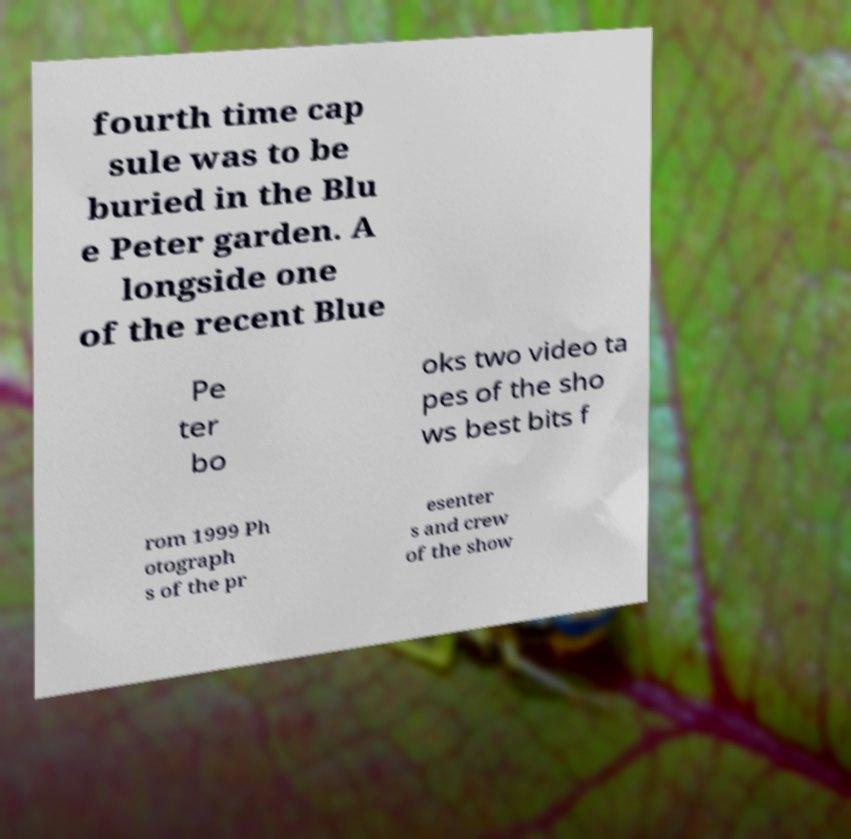Please identify and transcribe the text found in this image. fourth time cap sule was to be buried in the Blu e Peter garden. A longside one of the recent Blue Pe ter bo oks two video ta pes of the sho ws best bits f rom 1999 Ph otograph s of the pr esenter s and crew of the show 